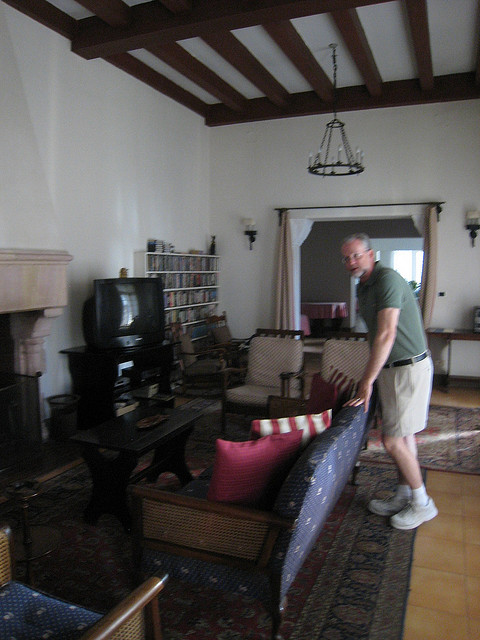<image>Is there a fire in this picture? There is no fire in the picture. Is there a fire in this picture? There is no fire in this picture. 